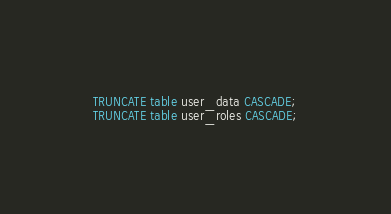<code> <loc_0><loc_0><loc_500><loc_500><_SQL_>TRUNCATE table user_data CASCADE;
TRUNCATE table user_roles CASCADE;
</code> 